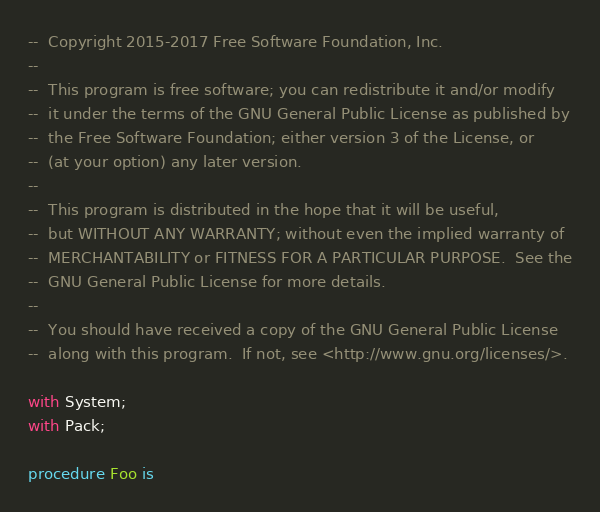<code> <loc_0><loc_0><loc_500><loc_500><_Ada_>--  Copyright 2015-2017 Free Software Foundation, Inc.
--
--  This program is free software; you can redistribute it and/or modify
--  it under the terms of the GNU General Public License as published by
--  the Free Software Foundation; either version 3 of the License, or
--  (at your option) any later version.
--
--  This program is distributed in the hope that it will be useful,
--  but WITHOUT ANY WARRANTY; without even the implied warranty of
--  MERCHANTABILITY or FITNESS FOR A PARTICULAR PURPOSE.  See the
--  GNU General Public License for more details.
--
--  You should have received a copy of the GNU General Public License
--  along with this program.  If not, see <http://www.gnu.org/licenses/>.

with System;
with Pack;

procedure Foo is</code> 